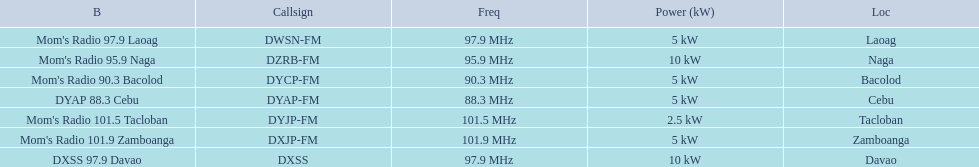Would you be able to parse every entry in this table? {'header': ['B', 'Callsign', 'Freq', 'Power (kW)', 'Loc'], 'rows': [["Mom's Radio 97.9 Laoag", 'DWSN-FM', '97.9\xa0MHz', '5\xa0kW', 'Laoag'], ["Mom's Radio 95.9 Naga", 'DZRB-FM', '95.9\xa0MHz', '10\xa0kW', 'Naga'], ["Mom's Radio 90.3 Bacolod", 'DYCP-FM', '90.3\xa0MHz', '5\xa0kW', 'Bacolod'], ['DYAP 88.3 Cebu', 'DYAP-FM', '88.3\xa0MHz', '5\xa0kW', 'Cebu'], ["Mom's Radio 101.5 Tacloban", 'DYJP-FM', '101.5\xa0MHz', '2.5\xa0kW', 'Tacloban'], ["Mom's Radio 101.9 Zamboanga", 'DXJP-FM', '101.9\xa0MHz', '5\xa0kW', 'Zamboanga'], ['DXSS 97.9 Davao', 'DXSS', '97.9\xa0MHz', '10\xa0kW', 'Davao']]} What is the only radio station with a frequency below 90 mhz? DYAP 88.3 Cebu. 